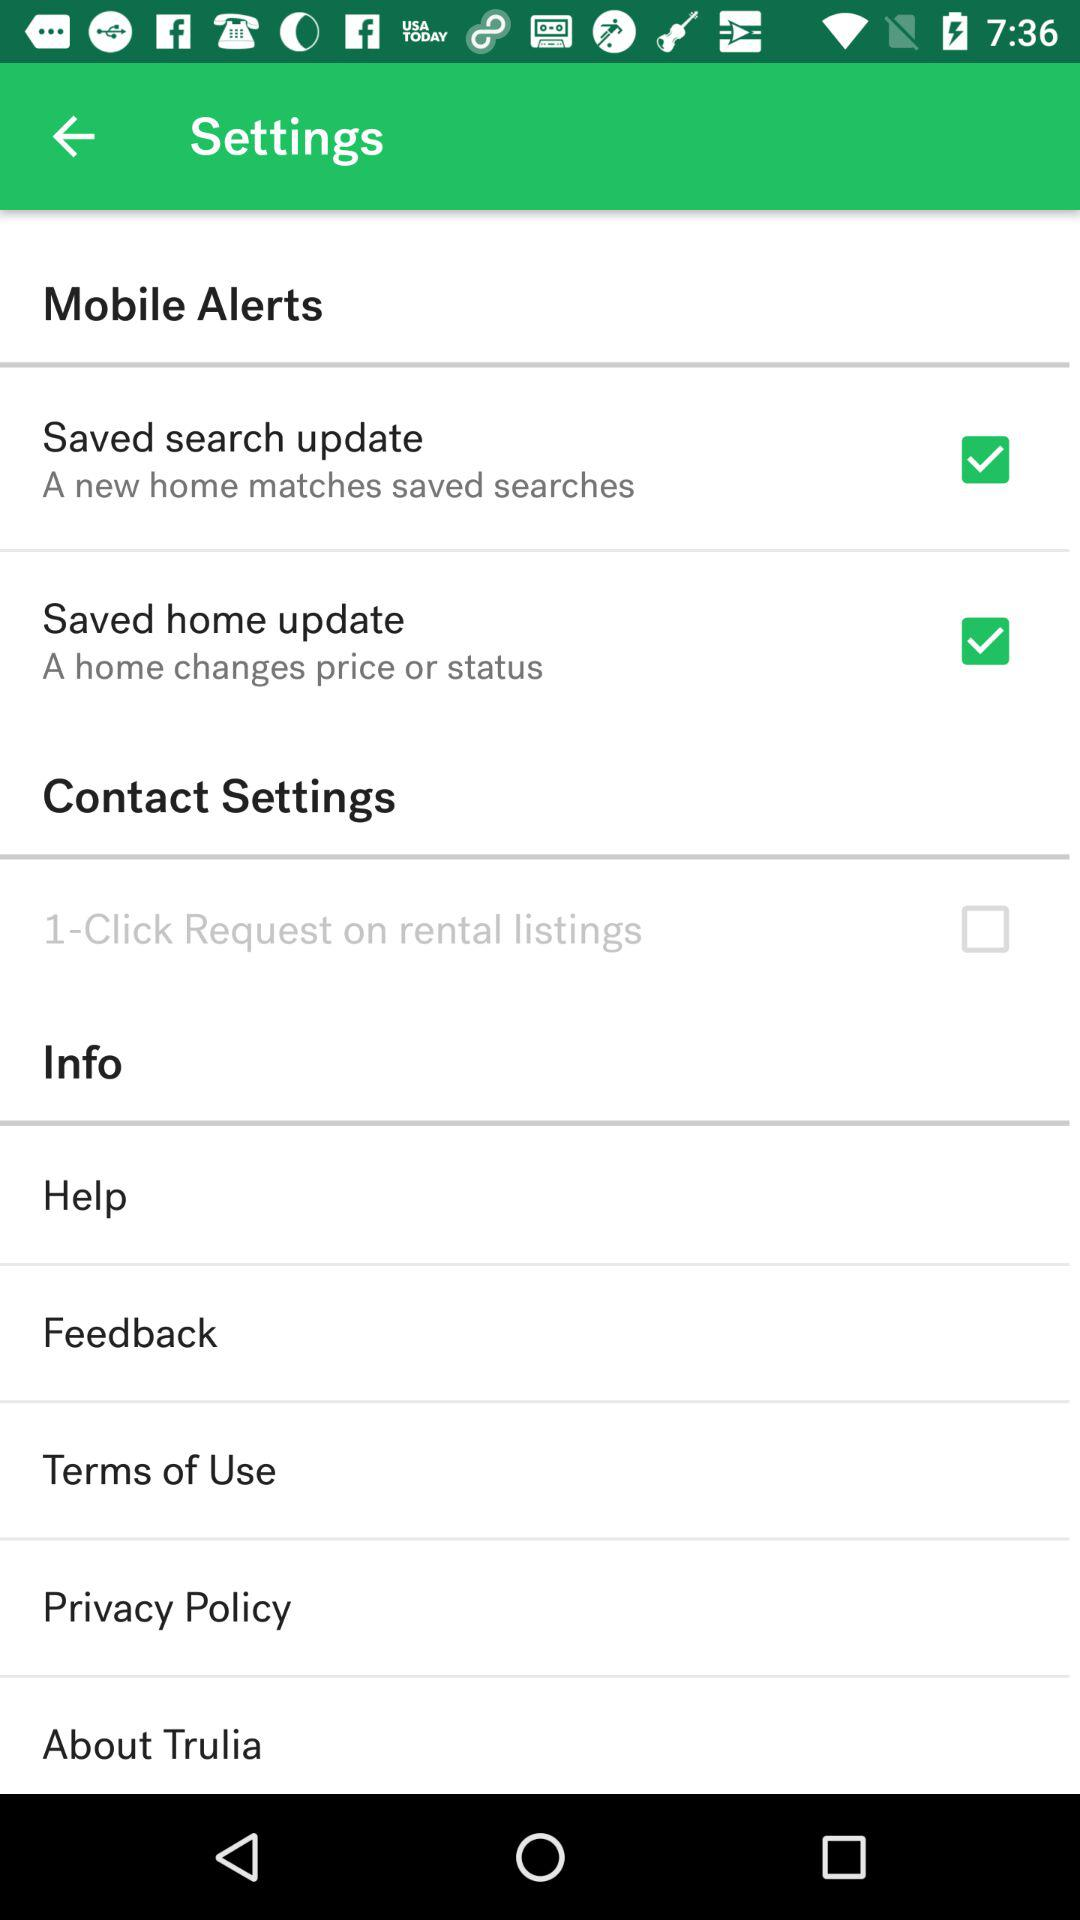What is the status of "Saved home update"? The status is "on". 